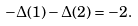Convert formula to latex. <formula><loc_0><loc_0><loc_500><loc_500>- \Delta ( 1 ) - \Delta ( 2 ) = - 2 .</formula> 